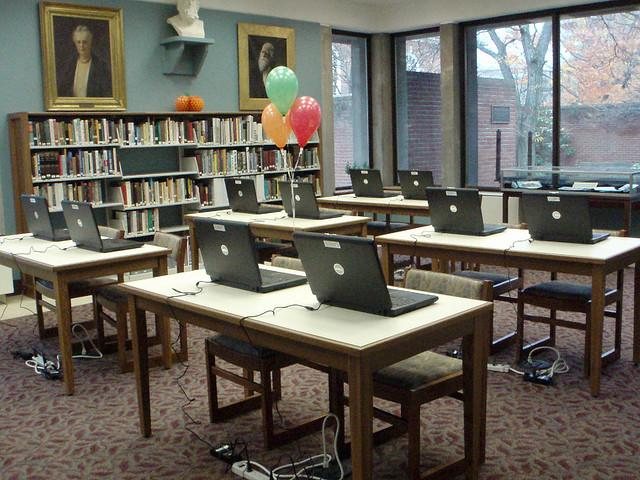What setting is this picture taken in?

Choices:
A) cafeteria
B) computer lab
C) classroom
D) laboratory computer lab 